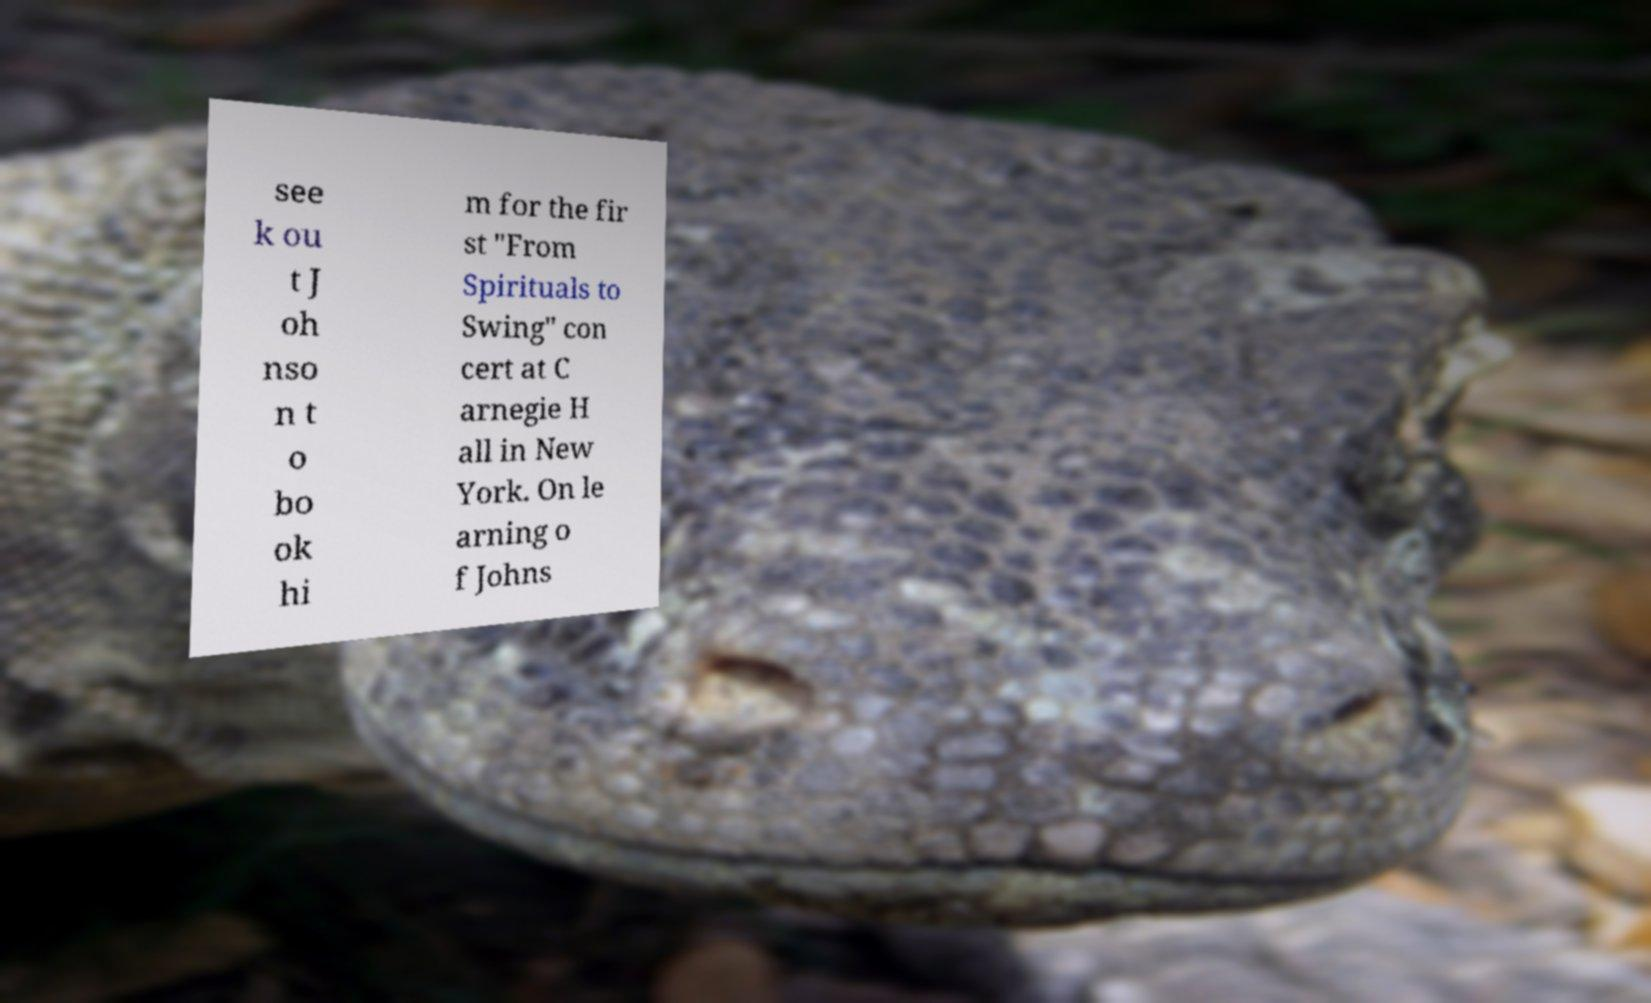What messages or text are displayed in this image? I need them in a readable, typed format. see k ou t J oh nso n t o bo ok hi m for the fir st "From Spirituals to Swing" con cert at C arnegie H all in New York. On le arning o f Johns 